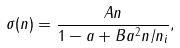<formula> <loc_0><loc_0><loc_500><loc_500>\sigma ( n ) = \frac { A n } { 1 - a + B a ^ { 2 } n / n _ { i } } ,</formula> 